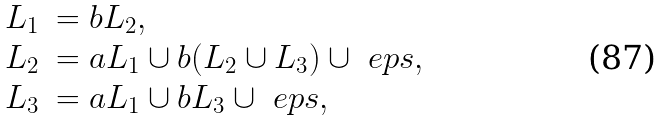<formula> <loc_0><loc_0><loc_500><loc_500>\begin{array} { r l } L _ { 1 } & = b L _ { 2 } , \\ L _ { 2 } & = a L _ { 1 } \cup b ( L _ { 2 } \cup L _ { 3 } ) \cup \ e p s , \\ L _ { 3 } & = a L _ { 1 } \cup b L _ { 3 } \cup \ e p s , \end{array}</formula> 